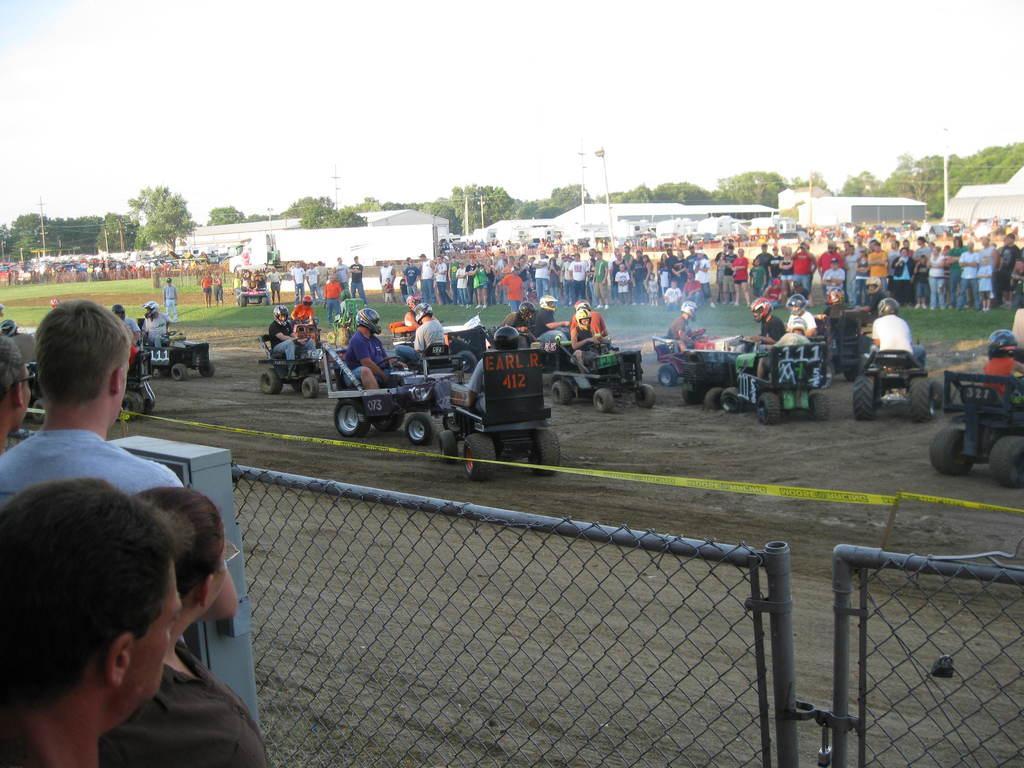Describe this image in one or two sentences. In the image I can see a group of people. Here we can see a few persons standing on the grass. Here we can see a few people sitting in the vehicles and there is a helmet on their heads. In the foreground we can see the metal fence. There are four persons on the left of the image. In the background, we can see the shed constructions and trees. 